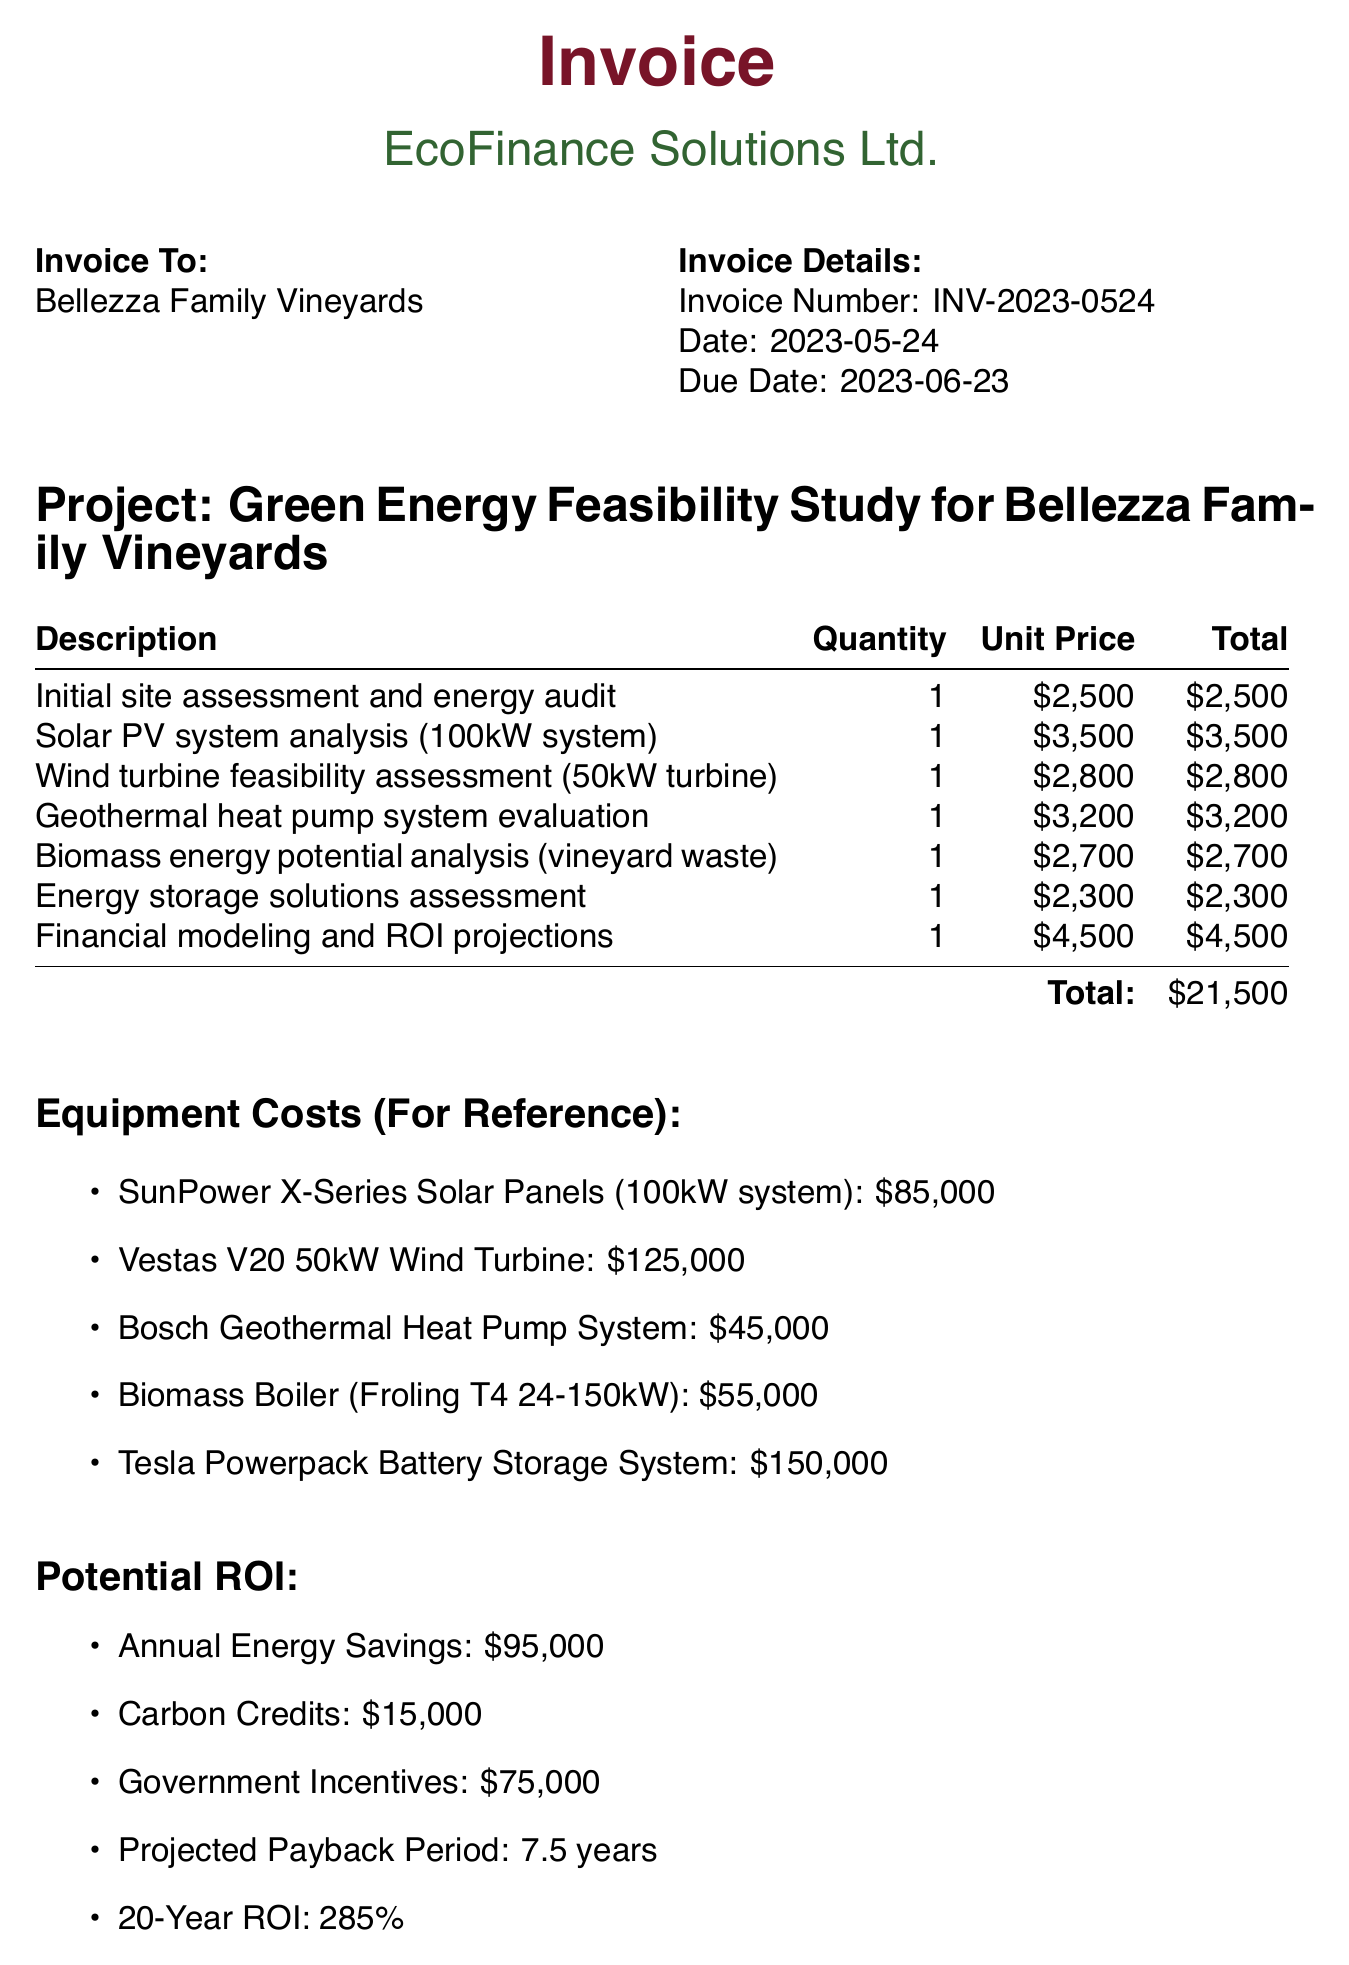what is the invoice number? The invoice number is specifically stated in the invoice details section.
Answer: INV-2023-0524 what is the total amount due? The total amount due is mentioned at the end of the line items section.
Answer: 21500 who is the consultant? The name of the consultant is provided in the invoice details.
Answer: Emma Greenfield what is the due date for payment? The due date is clearly listed under the invoice details.
Answer: 2023-06-23 how much do the solar PV system analysis costs? The cost for solar PV system analysis is mentioned in the line items.
Answer: 3500 what is the projected payback period for the investment? The payback period is part of the potential ROI section, which summarizes financial projections.
Answer: 7.5 years what is included in the additional notes? The additional notes provide insights into the feasibility study, relevant incentives, and potential benefits highlighted there.
Answer: Government grants analysis what item has the highest equipment cost? The equipment costs section lists different items with their costs.
Answer: Vestas V20 50kW Wind Turbine what percentage is the 20-year ROI? The 20-year ROI is clearly stated in the potential ROI section.
Answer: 285% 